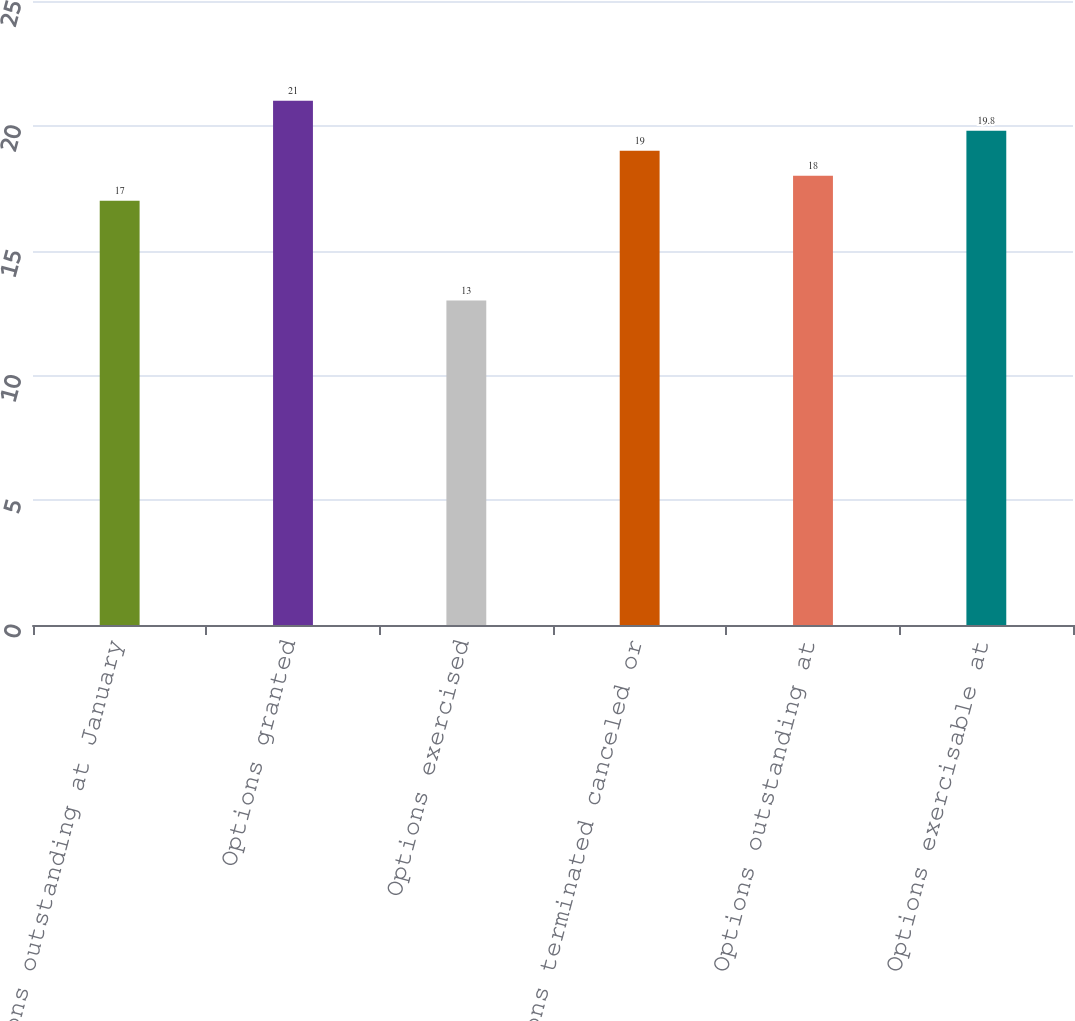Convert chart to OTSL. <chart><loc_0><loc_0><loc_500><loc_500><bar_chart><fcel>Options outstanding at January<fcel>Options granted<fcel>Options exercised<fcel>Options terminated canceled or<fcel>Options outstanding at<fcel>Options exercisable at<nl><fcel>17<fcel>21<fcel>13<fcel>19<fcel>18<fcel>19.8<nl></chart> 